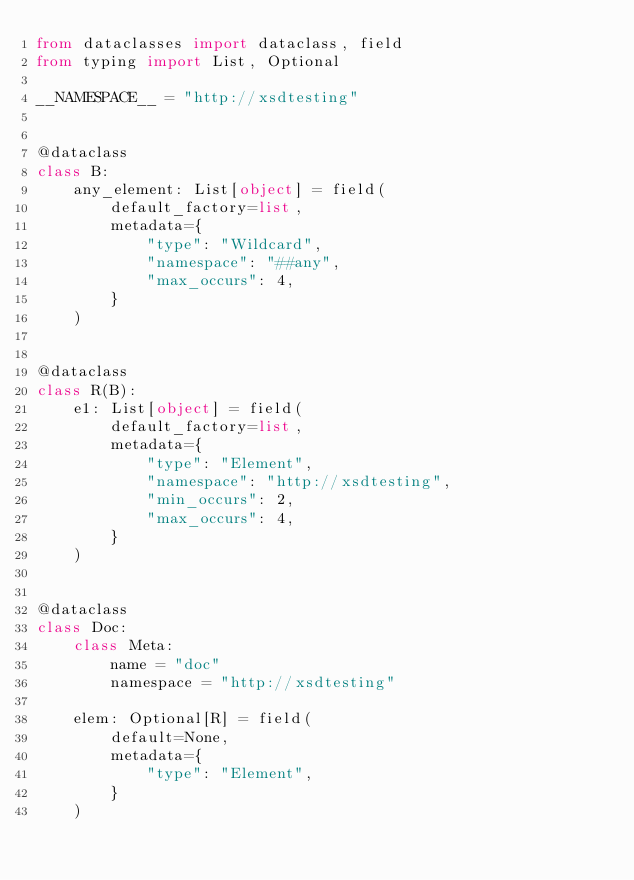<code> <loc_0><loc_0><loc_500><loc_500><_Python_>from dataclasses import dataclass, field
from typing import List, Optional

__NAMESPACE__ = "http://xsdtesting"


@dataclass
class B:
    any_element: List[object] = field(
        default_factory=list,
        metadata={
            "type": "Wildcard",
            "namespace": "##any",
            "max_occurs": 4,
        }
    )


@dataclass
class R(B):
    e1: List[object] = field(
        default_factory=list,
        metadata={
            "type": "Element",
            "namespace": "http://xsdtesting",
            "min_occurs": 2,
            "max_occurs": 4,
        }
    )


@dataclass
class Doc:
    class Meta:
        name = "doc"
        namespace = "http://xsdtesting"

    elem: Optional[R] = field(
        default=None,
        metadata={
            "type": "Element",
        }
    )
</code> 